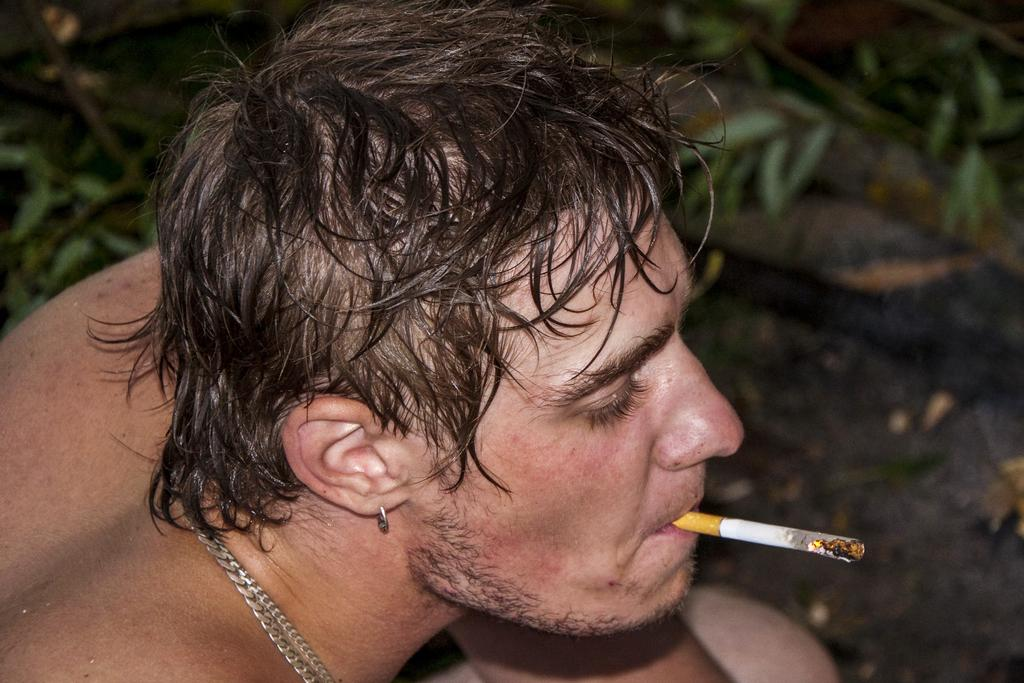Who is present in the image? There is a man in the image. Where is the man positioned in the image? The man is positioned towards the left side. What is the man holding in his mouth? The man has a cigarette in his mouth. What can be seen in the background of the image? There are plants in the background of the image. What type of record can be seen on the wall in the image? There is no record present on the wall in the image. 